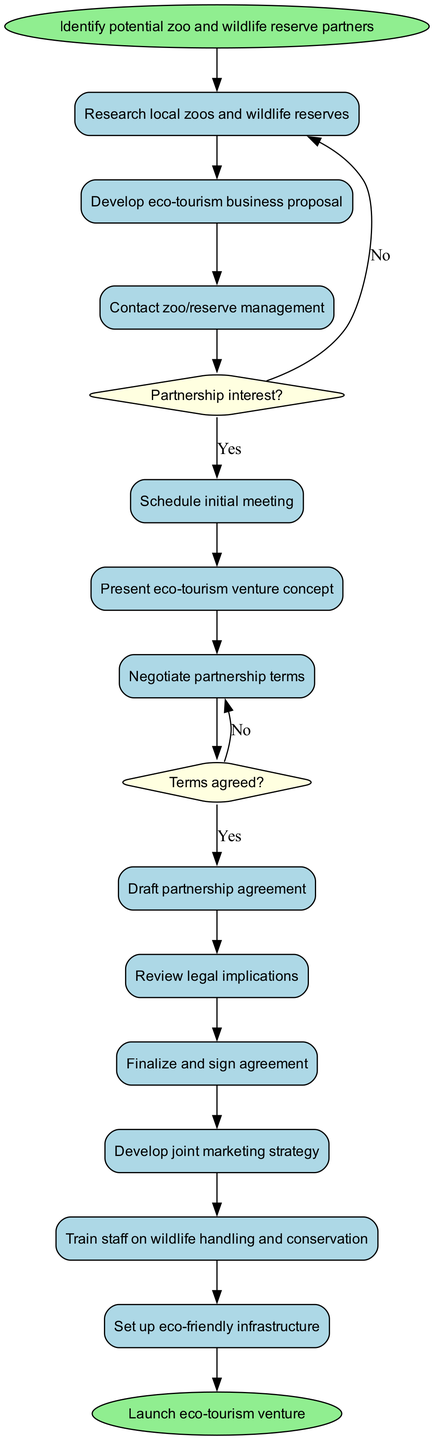What is the first activity in the process? The first activity node after the start node is "Research local zoos and wildlife reserves", which directly follows the start node.
Answer: Research local zoos and wildlife reserves How many decision nodes are present in the diagram? By counting the diamond-shaped nodes in the diagram, we find there are two decision nodes: one for "Partnership interest?" and another for "Terms agreed?".
Answer: 2 What happens after "Negotiate partnership terms" if terms are not agreed? The diagram indicates that if the terms are not agreed at the "Negotiate partnership terms" point, the next node will be to "Renegotiate or seek alternatives".
Answer: Renegotiate or seek alternatives How does the flow proceed after "Contact zoo/reserve management"? After "Contact zoo/reserve management", there is a decision node for "Partnership interest?". If the answer is yes, the flow leads to "Schedule initial meeting"; if no, it goes back to "Research alternative partners".
Answer: Schedule initial meeting or Research alternative partners What is the last activity before launching the venture? The last activity node before the end node, which indicates the launch of the eco-tourism venture, is "Set up eco-friendly infrastructure".
Answer: Set up eco-friendly infrastructure Which activity is connected to the decision "Partnership interest?" if the answer is no? If the answer to the decision "Partnership interest?" is no, the flow leads to "Research alternative partners", indicating a need to look for different partners.
Answer: Research alternative partners What is the end goal of this process as indicated by the end node? The end node specifies the final outcome of the entire process, which is to "Launch eco-tourism venture".
Answer: Launch eco-tourism venture What activity directly follows "Draft partnership agreement"? Following the "Draft partnership agreement", the next activity in the flow is "Review legal implications".
Answer: Review legal implications How many activities are listed in the diagram? By counting the rectangular nodes except for the start and end, we can find that there are twelve activities listed in the diagram.
Answer: 12 